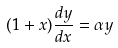Convert formula to latex. <formula><loc_0><loc_0><loc_500><loc_500>( 1 + x ) \frac { d y } { d x } = \alpha y</formula> 